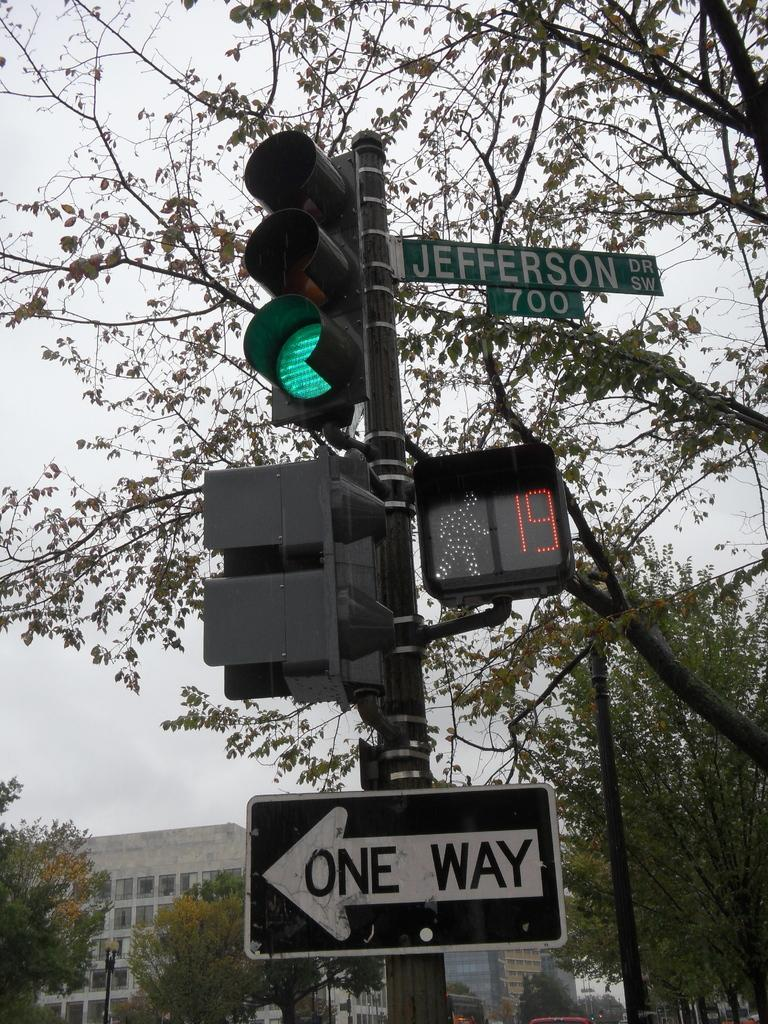Provide a one-sentence caption for the provided image. Signs on a traffic light showing that Jefferson Drive is a one way street. 